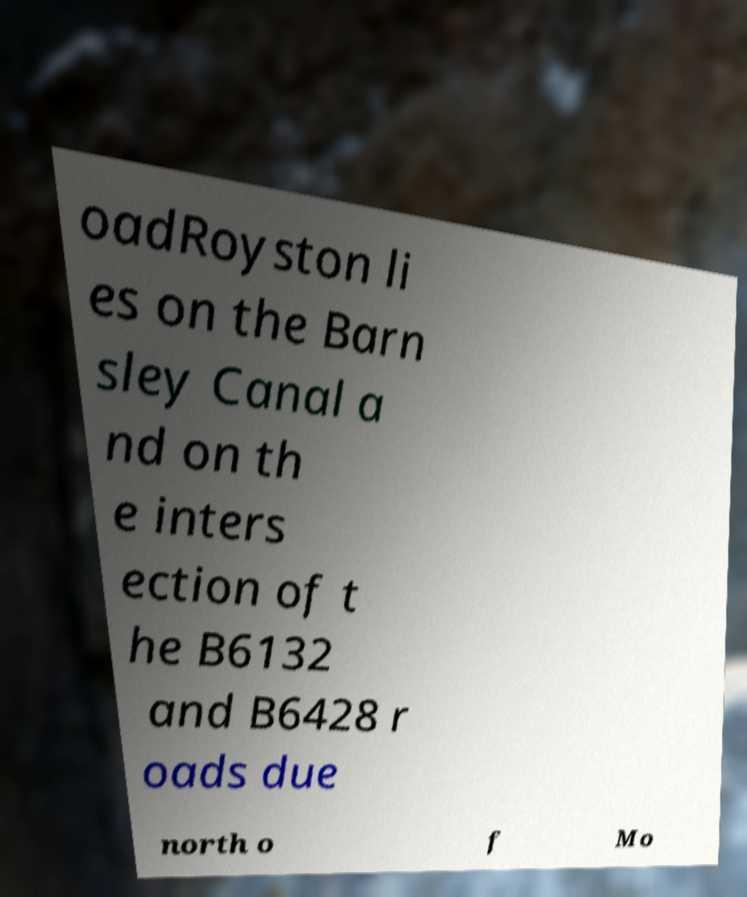Could you assist in decoding the text presented in this image and type it out clearly? oadRoyston li es on the Barn sley Canal a nd on th e inters ection of t he B6132 and B6428 r oads due north o f Mo 